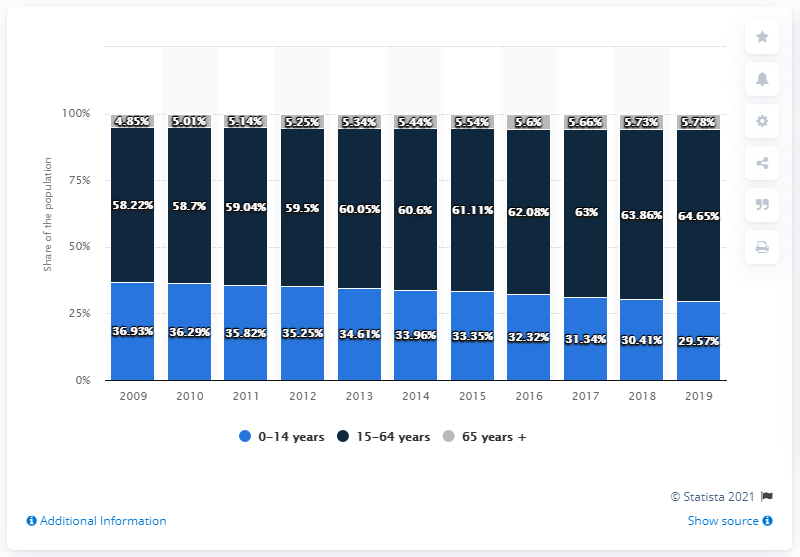Identify some key points in this picture. The difference between the maximum percentage of people in the age group 15-64 years and the minimum percentage of people in the age group 0-14 over the years is 35.08%. In 2014, approximately 33.96% of the global population fell within the age group of 0-14 years old. 